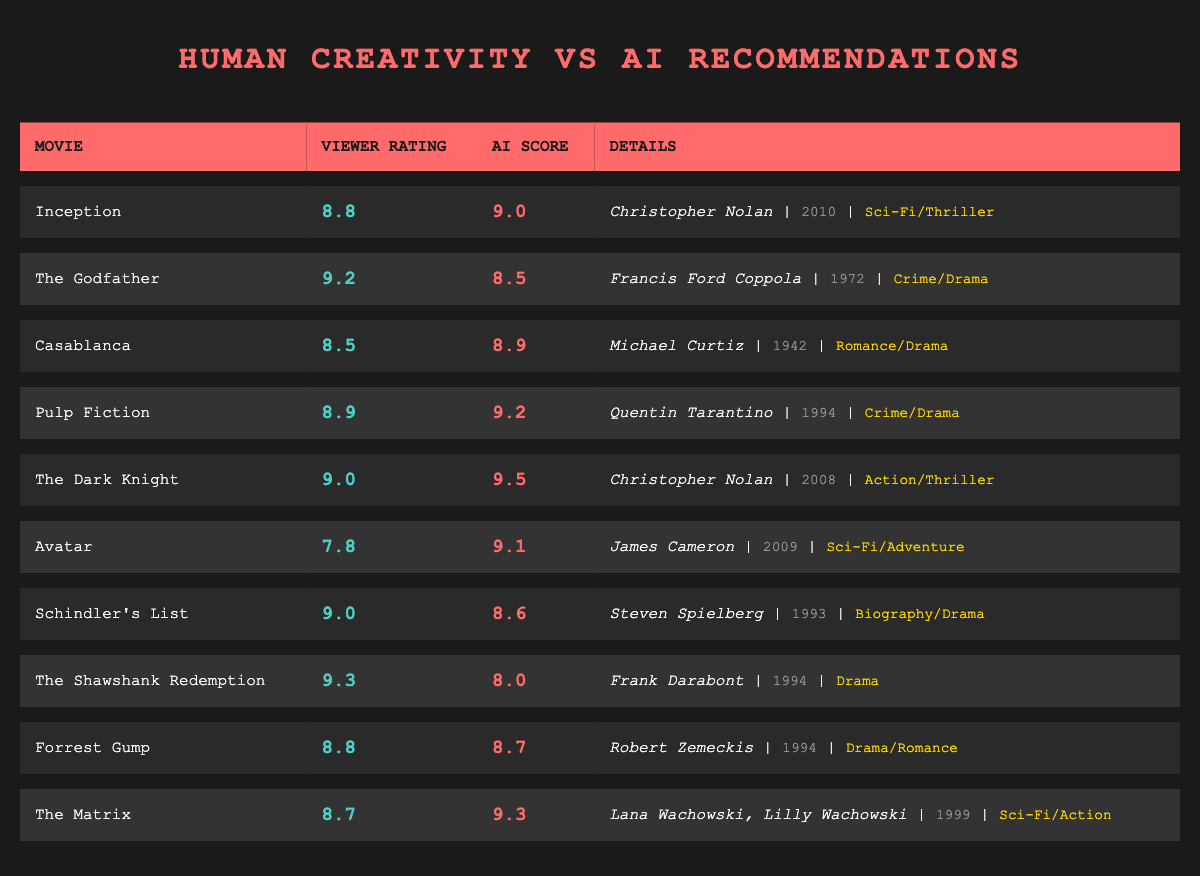What is the viewer rating of "Inception"? The table lists "Inception" with a viewer rating of 8.8.
Answer: 8.8 Which movie has the highest viewer rating? By examining the table, "The Shawshank Redemption" has the highest viewer rating at 9.3.
Answer: The Shawshank Redemption What is the AI recommendation score for "Avatar"? The AI recommendation score for "Avatar," as shown in the table, is 9.1.
Answer: 9.1 Which movie has the biggest difference between viewer rating and AI recommendation score? The difference for each movie is calculated as the absolute value of viewer rating minus AI recommendation score. The largest difference is for "The Shawshank Redemption" with a difference of 1.3 (9.3 - 8.0).
Answer: The Shawshank Redemption Is "The Dark Knight" rated higher by viewers or AI? The viewer rating for "The Dark Knight" is 9.0, while the AI score is 9.5. Since 9.5 is greater than 9.0, the AI rated it higher.
Answer: Yes What is the average viewer rating of all movies in the table? The viewer ratings are 8.8, 9.2, 8.5, 8.9, 9.0, 7.8, 9.0, 9.3, 8.8, and 8.7, totaling 88.8. Dividing by 10 (the number of movies), the average rating is 8.88.
Answer: 8.88 How many movies have AI recommendation scores higher than their viewer ratings? By looking at the scores, the movies with AI recommendation scores higher than viewer ratings are "Inception," "Pulp Fiction," "The Dark Knight," and "Avatar," totaling 4 movies.
Answer: 4 What genre is "Casablanca" classified under? According to the table, "Casablanca" is classified as Romance/Drama.
Answer: Romance/Drama What is the lowest AI recommendation score among the movies? In the table, "The Shawshank Redemption" has the lowest AI recommendation score, which is 8.0.
Answer: 8.0 Which director has the most movies listed in the table? "Christopher Nolan" directed two movies: "Inception" and "The Dark Knight." No other director has more than one movie listed.
Answer: Christopher Nolan Is there a movie from 2009 in the table, and if so, what is its viewer rating? Yes, "Avatar" was released in 2009 and has a viewer rating of 7.8.
Answer: Yes, viewer rating is 7.8 